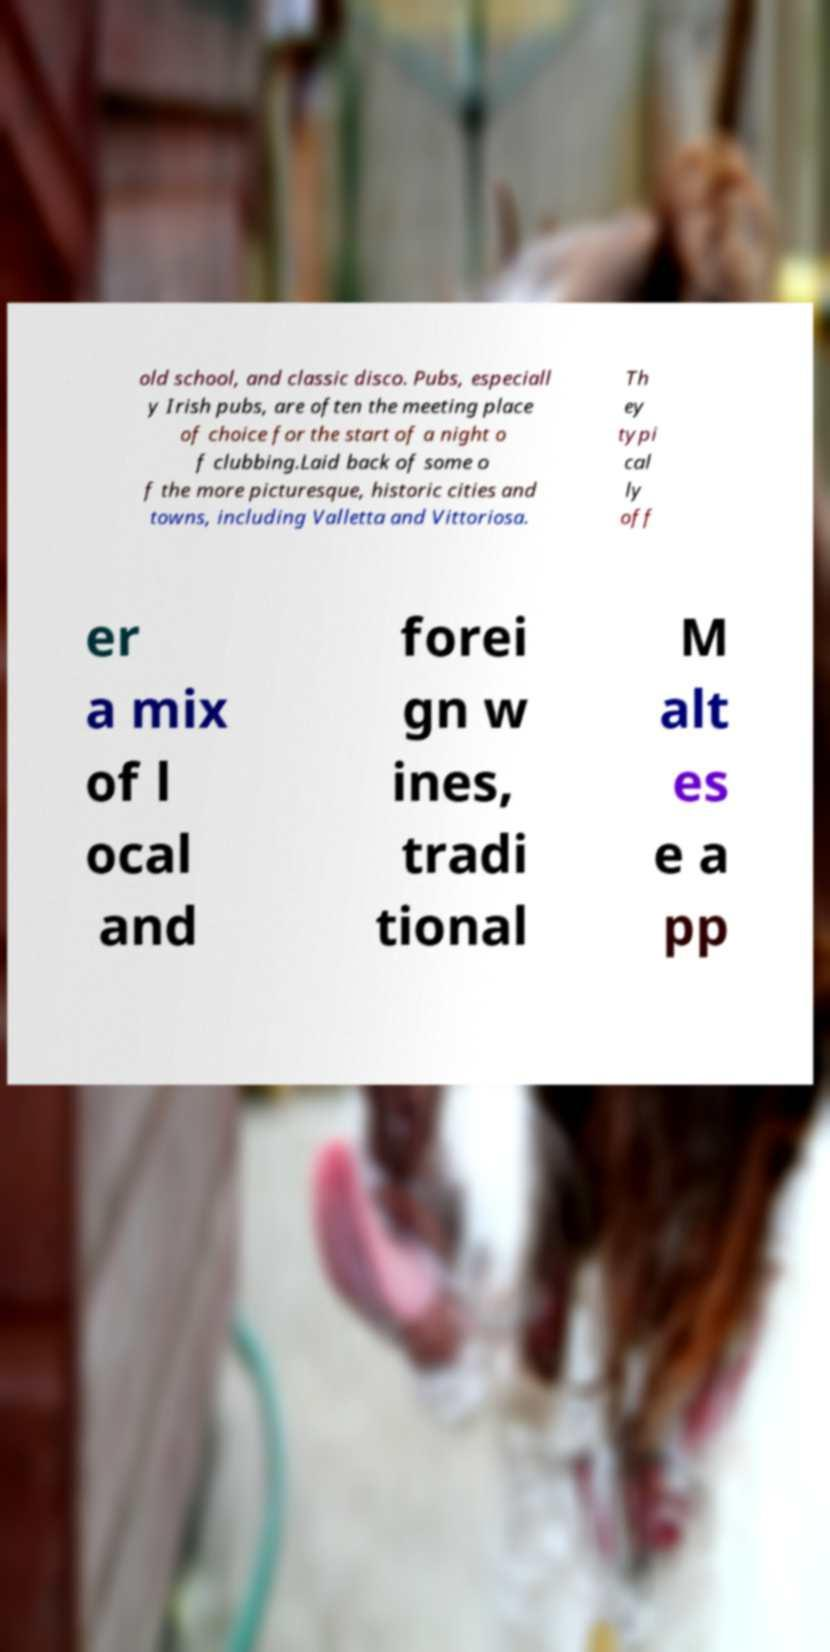Could you assist in decoding the text presented in this image and type it out clearly? old school, and classic disco. Pubs, especiall y Irish pubs, are often the meeting place of choice for the start of a night o f clubbing.Laid back of some o f the more picturesque, historic cities and towns, including Valletta and Vittoriosa. Th ey typi cal ly off er a mix of l ocal and forei gn w ines, tradi tional M alt es e a pp 